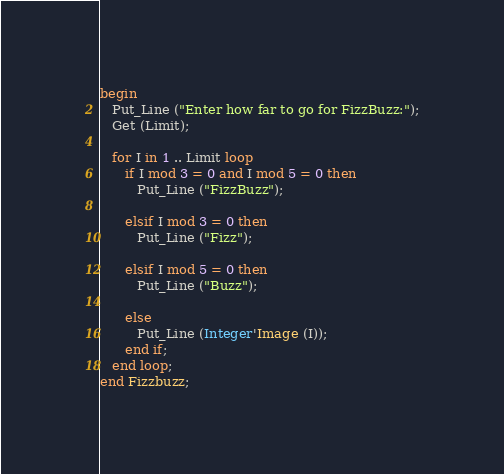Convert code to text. <code><loc_0><loc_0><loc_500><loc_500><_Ada_>begin
   Put_Line ("Enter how far to go for FizzBuzz:");
   Get (Limit);

   for I in 1 .. Limit loop
      if I mod 3 = 0 and I mod 5 = 0 then
         Put_Line ("FizzBuzz");

      elsif I mod 3 = 0 then
         Put_Line ("Fizz");

      elsif I mod 5 = 0 then
         Put_Line ("Buzz");

      else
         Put_Line (Integer'Image (I));
      end if;
   end loop;
end Fizzbuzz;
</code> 